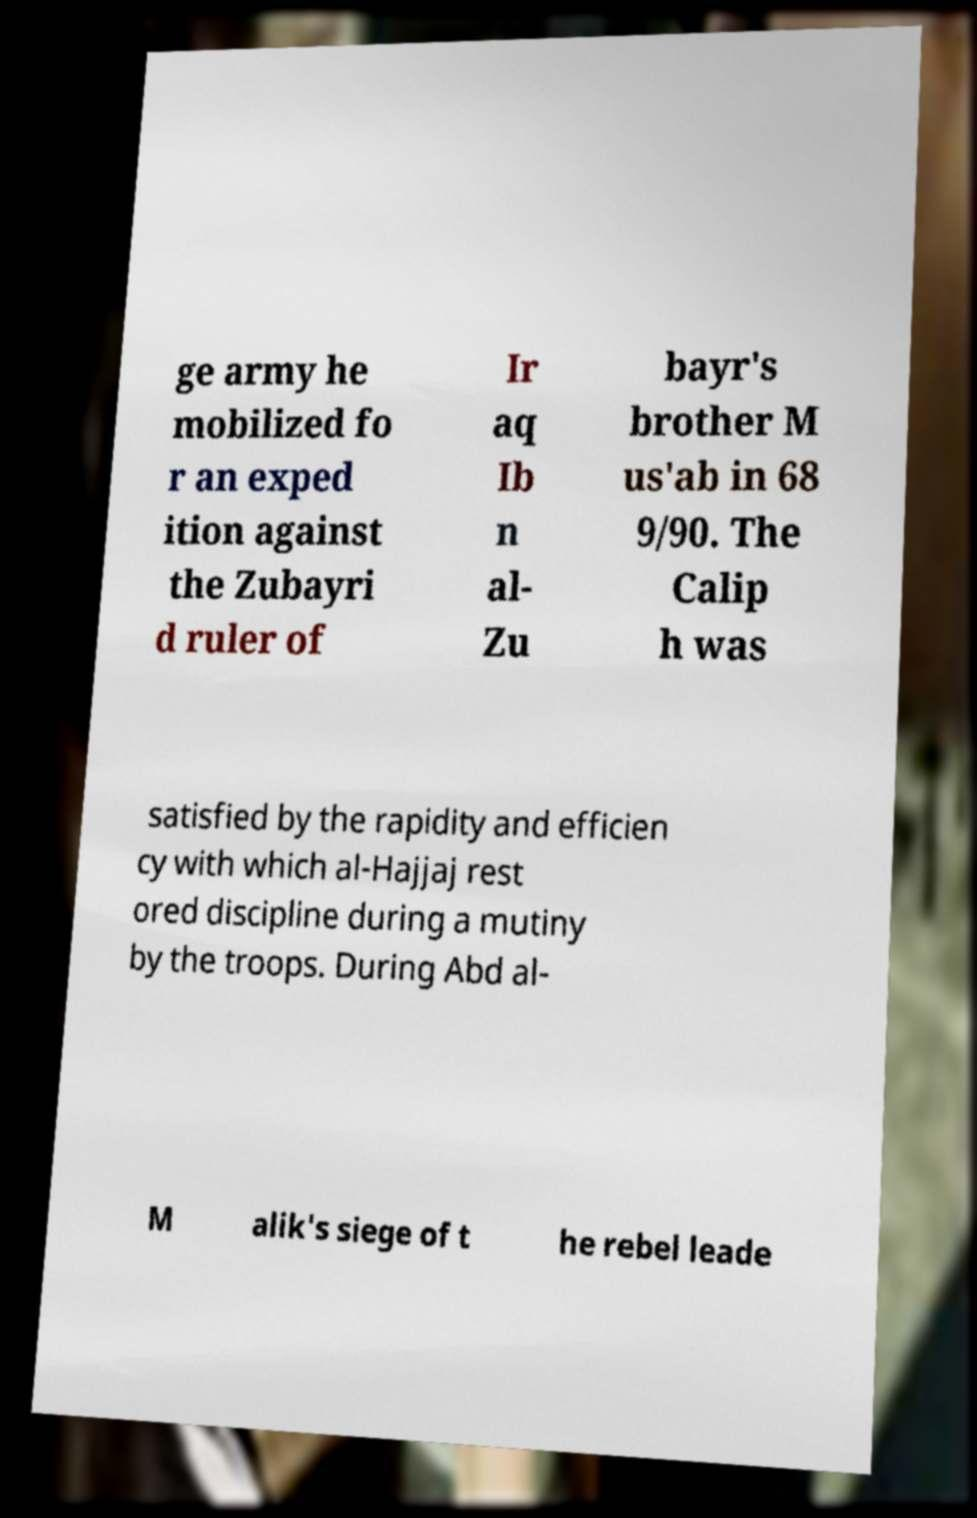Can you read and provide the text displayed in the image?This photo seems to have some interesting text. Can you extract and type it out for me? ge army he mobilized fo r an exped ition against the Zubayri d ruler of Ir aq Ib n al- Zu bayr's brother M us'ab in 68 9/90. The Calip h was satisfied by the rapidity and efficien cy with which al-Hajjaj rest ored discipline during a mutiny by the troops. During Abd al- M alik's siege of t he rebel leade 